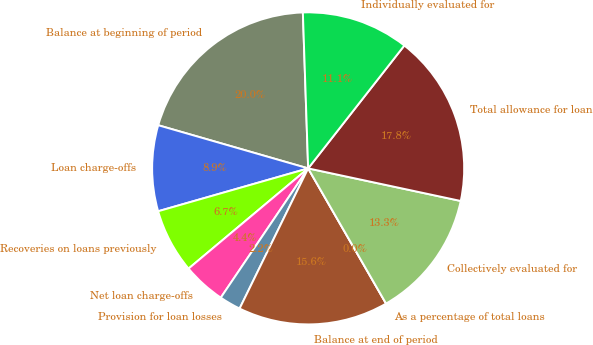Convert chart. <chart><loc_0><loc_0><loc_500><loc_500><pie_chart><fcel>Balance at beginning of period<fcel>Loan charge-offs<fcel>Recoveries on loans previously<fcel>Net loan charge-offs<fcel>Provision for loan losses<fcel>Balance at end of period<fcel>As a percentage of total loans<fcel>Collectively evaluated for<fcel>Total allowance for loan<fcel>Individually evaluated for<nl><fcel>20.0%<fcel>8.89%<fcel>6.67%<fcel>4.44%<fcel>2.22%<fcel>15.56%<fcel>0.0%<fcel>13.33%<fcel>17.78%<fcel>11.11%<nl></chart> 